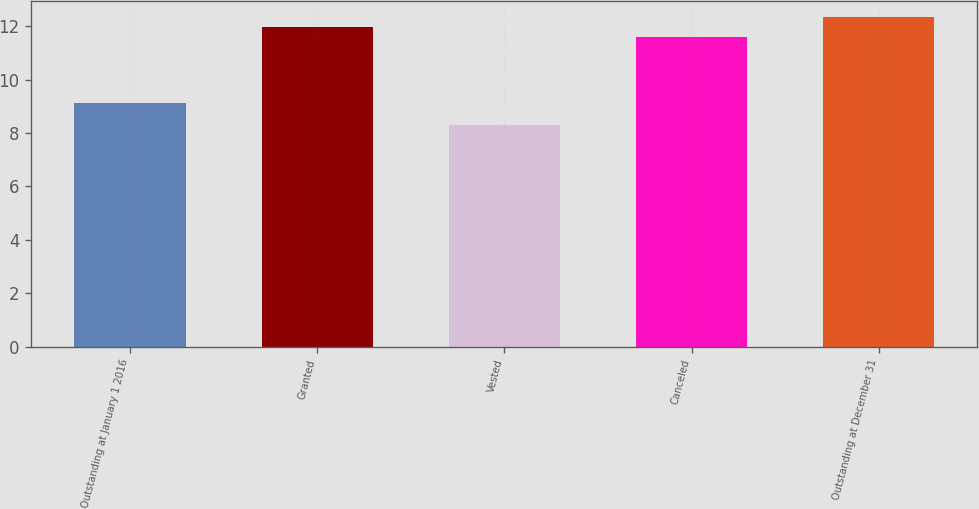<chart> <loc_0><loc_0><loc_500><loc_500><bar_chart><fcel>Outstanding at January 1 2016<fcel>Granted<fcel>Vested<fcel>Canceled<fcel>Outstanding at December 31<nl><fcel>9.14<fcel>11.97<fcel>8.31<fcel>11.6<fcel>12.34<nl></chart> 